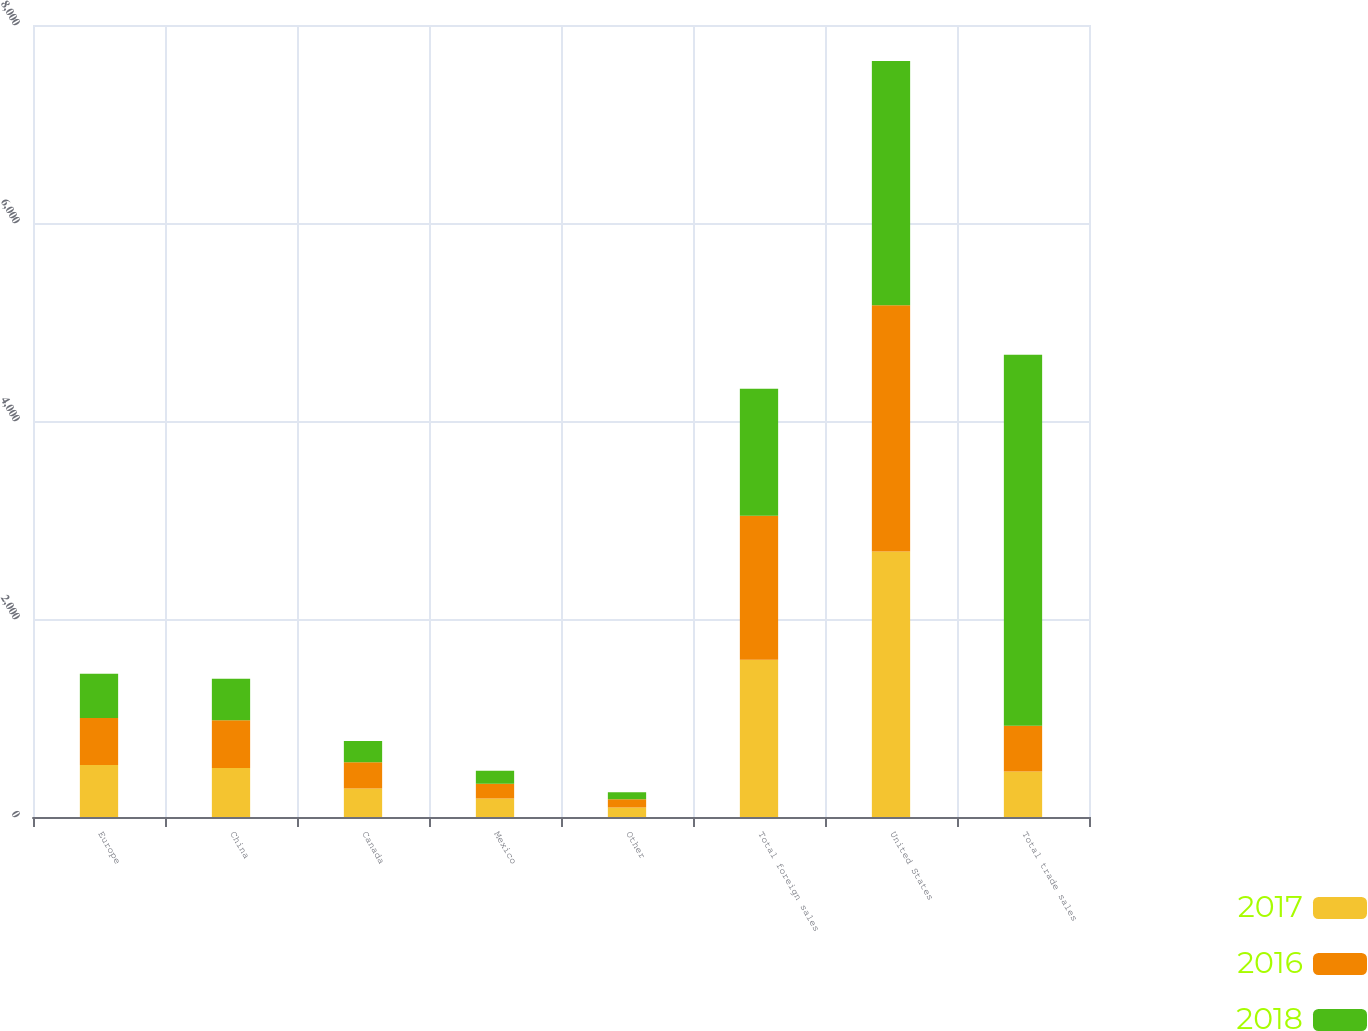Convert chart to OTSL. <chart><loc_0><loc_0><loc_500><loc_500><stacked_bar_chart><ecel><fcel>Europe<fcel>China<fcel>Canada<fcel>Mexico<fcel>Other<fcel>Total foreign sales<fcel>United States<fcel>Total trade sales<nl><fcel>2017<fcel>525.6<fcel>494.7<fcel>286.8<fcel>186.1<fcel>94.8<fcel>1588<fcel>2681.5<fcel>460.25<nl><fcel>2016<fcel>475.3<fcel>481.6<fcel>265.1<fcel>148.5<fcel>85.5<fcel>1456<fcel>2487.8<fcel>460.25<nl><fcel>2018<fcel>445.2<fcel>420<fcel>215.1<fcel>132.8<fcel>69.4<fcel>1282.5<fcel>2467.4<fcel>3749.9<nl></chart> 